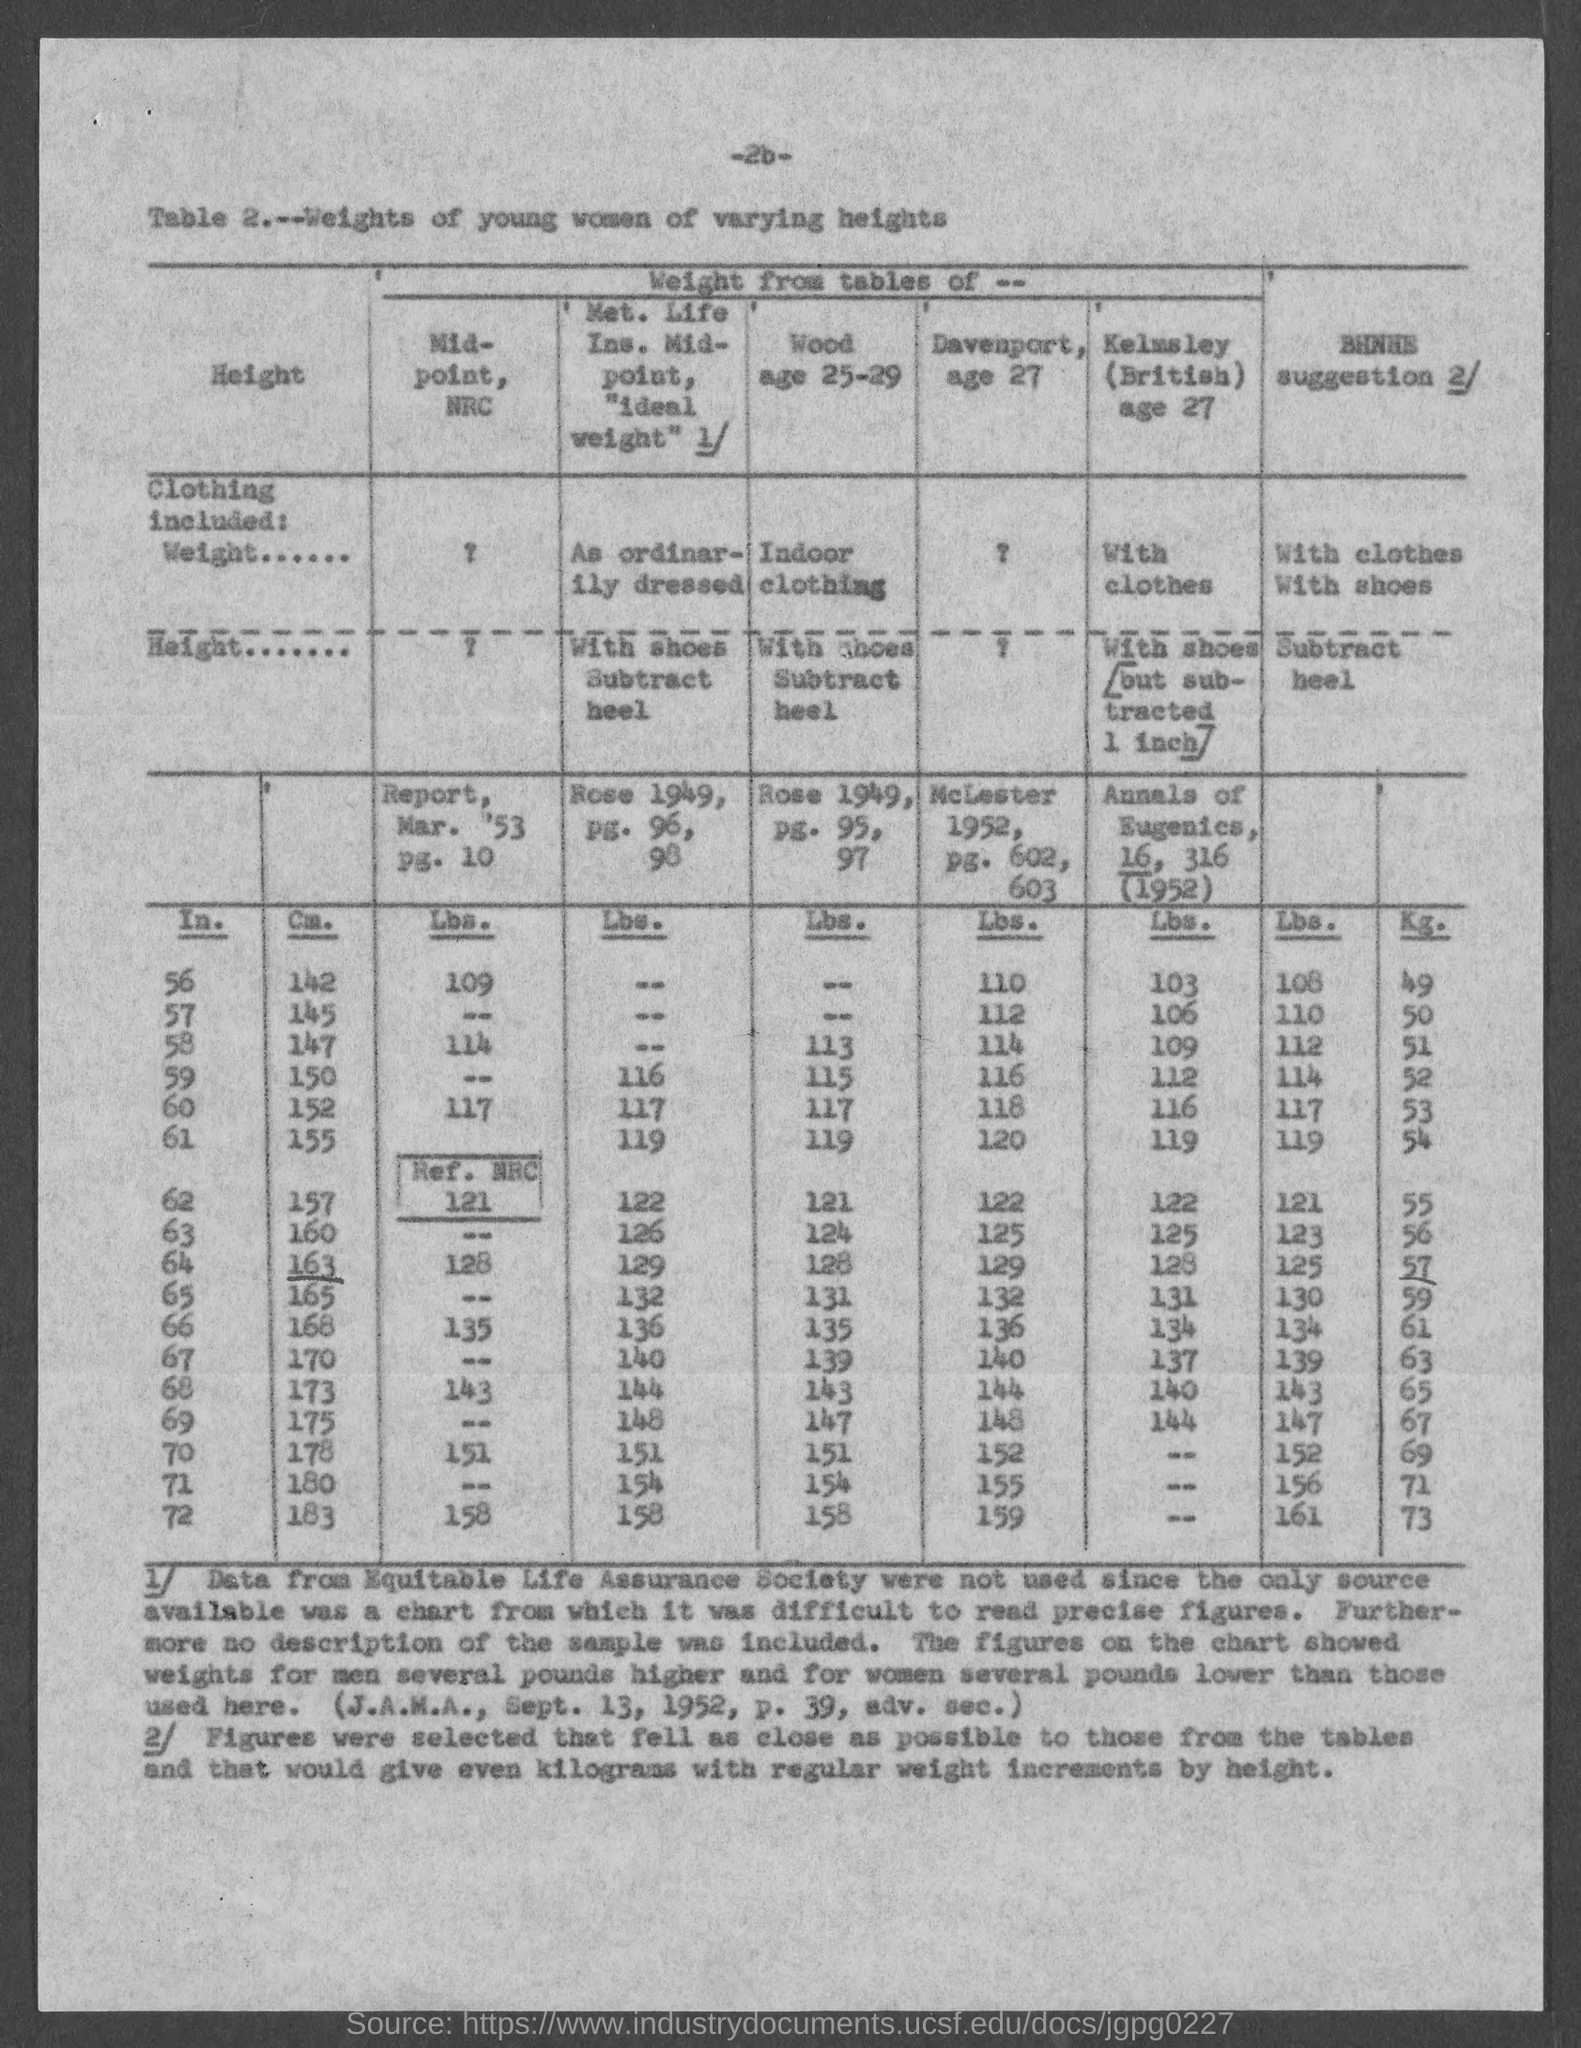What is the page number at top of the page?
Offer a very short reply. 26. What is the title of the table?
Keep it short and to the point. Weights of young women of varying heights. 